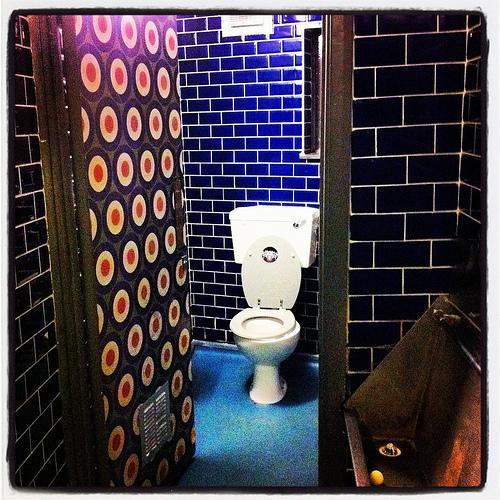How many toilets are there?
Give a very brief answer. 1. 